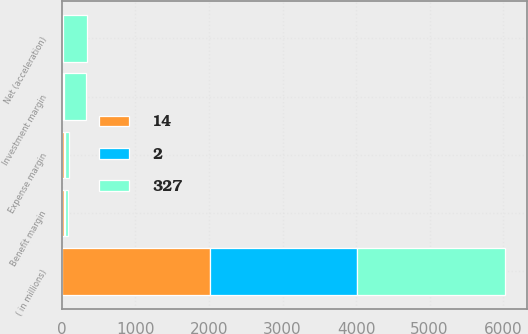<chart> <loc_0><loc_0><loc_500><loc_500><stacked_bar_chart><ecel><fcel>( in millions)<fcel>Investment margin<fcel>Benefit margin<fcel>Expense margin<fcel>Net (acceleration)<nl><fcel>327<fcel>2008<fcel>303<fcel>35<fcel>59<fcel>327<nl><fcel>14<fcel>2007<fcel>11<fcel>34<fcel>31<fcel>14<nl><fcel>2<fcel>2006<fcel>15<fcel>13<fcel>4<fcel>2<nl></chart> 